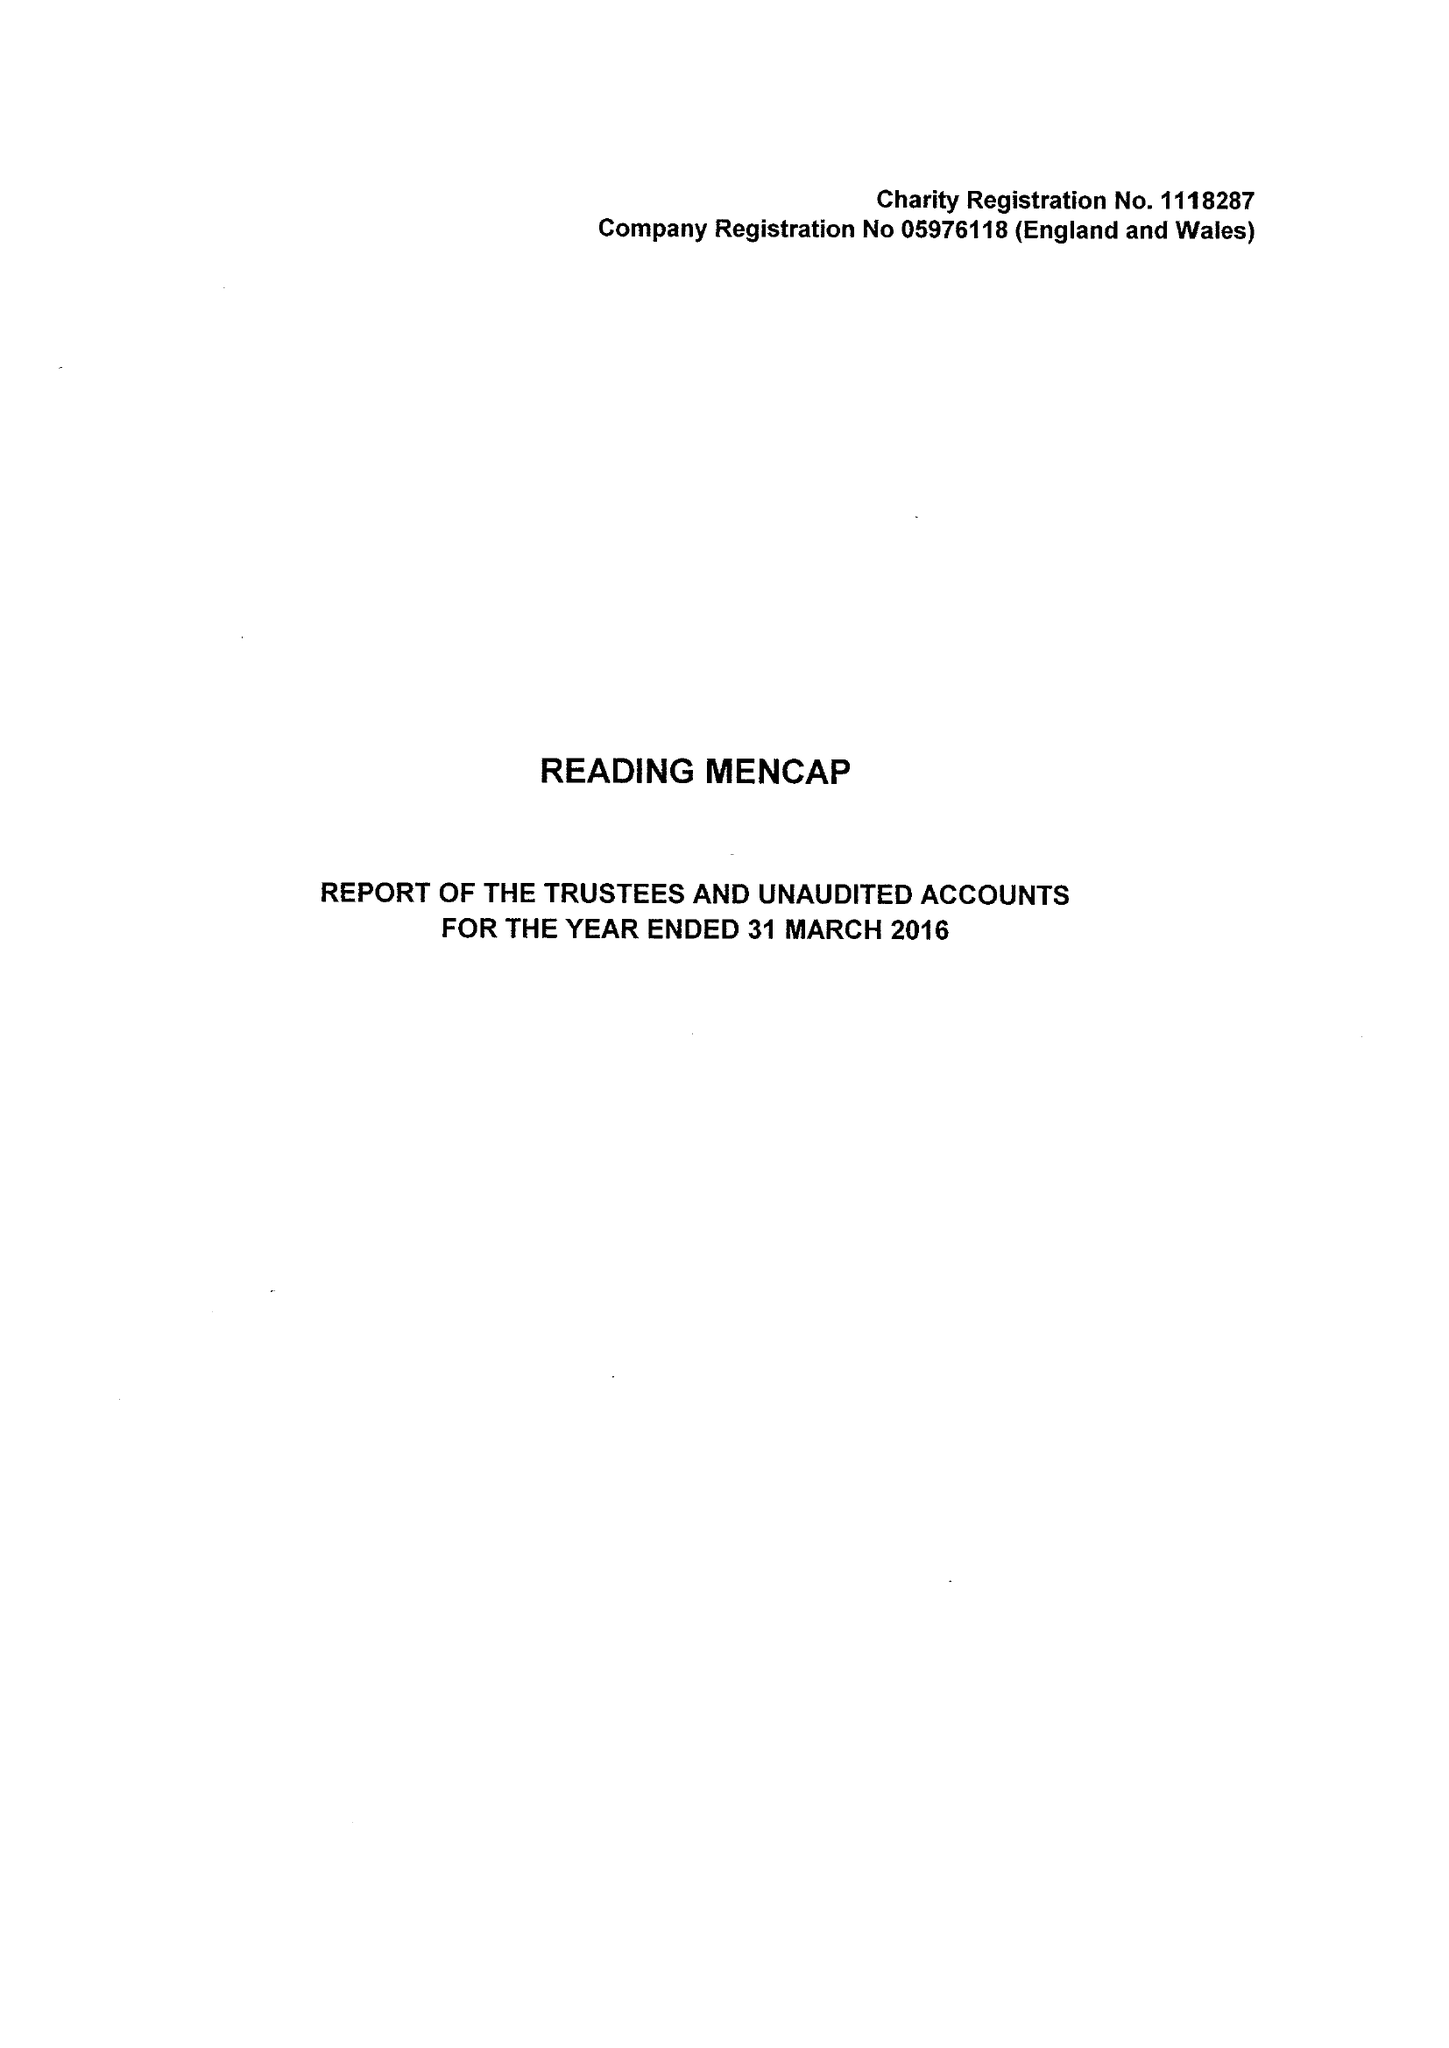What is the value for the income_annually_in_british_pounds?
Answer the question using a single word or phrase. 307166.00 